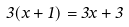<formula> <loc_0><loc_0><loc_500><loc_500>3 ( x + 1 ) = 3 x + 3</formula> 